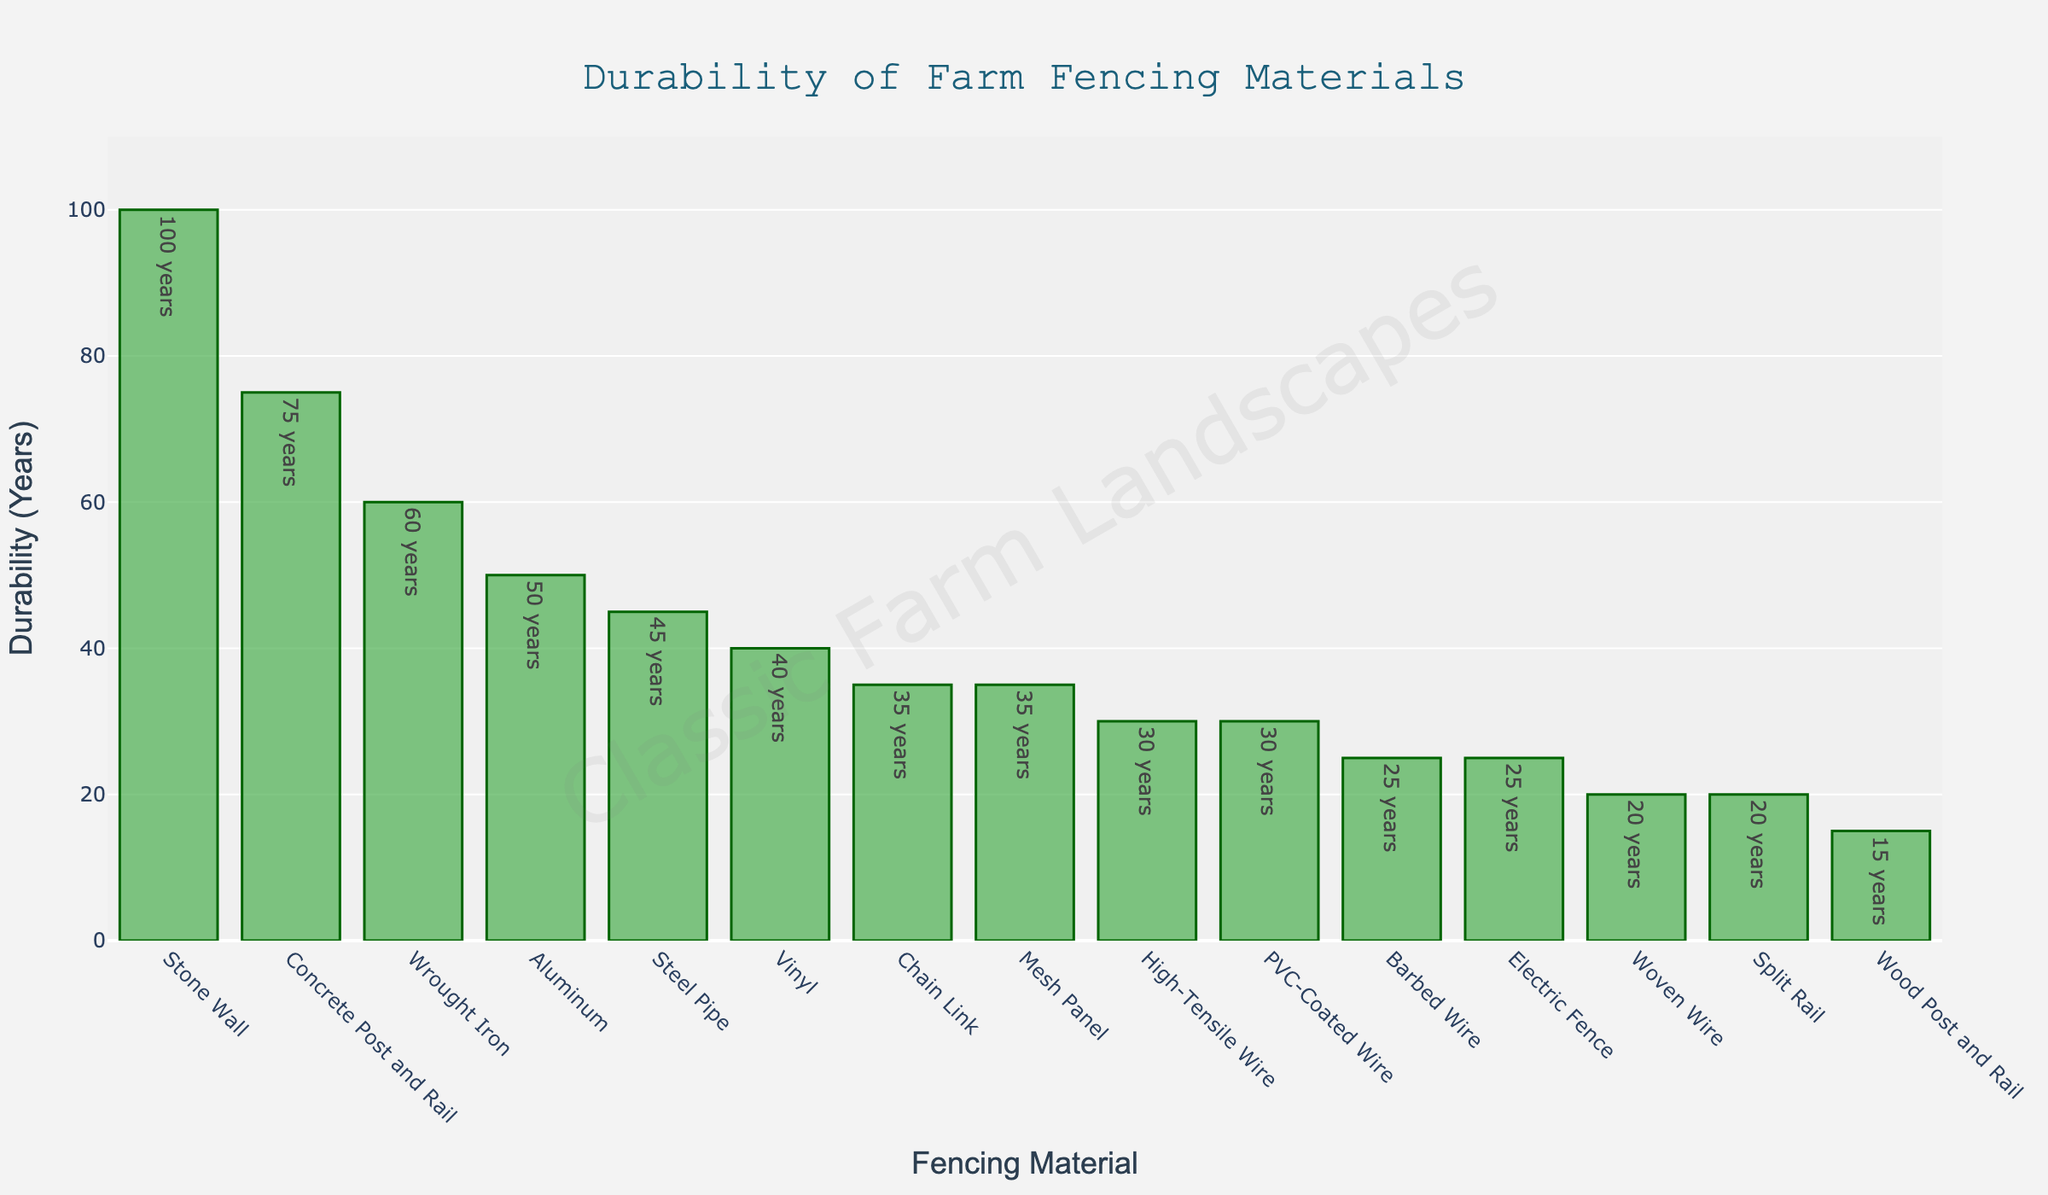What material has the highest durability rating? Identify the highest bar on the chart. The material for the highest bar is Stone Wall with a durability rating of 100 years.
Answer: Stone Wall Which materials have a durability rating of 35 years? Find all bars that are labeled with a durability of 35 years. Chain Link and Mesh Panel both have a 35-year rating.
Answer: Chain Link, Mesh Panel How does the durability of Wrought Iron compare to that of Vinyl? Locate the bars for Wrought Iron and Vinyl. Wrought Iron has a higher durability rating (60 years) compared to Vinyl (40 years).
Answer: Wrought Iron is more durable What is the difference in durability rating between the least durable and most durable materials? Identify the materials with the highest and lowest durability ratings (100 years for Stone Wall and 15 years for Wood Post and Rail respectively). Subtract the lowest from the highest: 100 - 15 = 85.
Answer: 85 years Which material has a durability rating closest to 50 years? Find the bar closest to the 50-year mark. Aluminum has a rating of 50 years, exactly matching the criterion.
Answer: Aluminum What is the total durability rating of Woven Wire, Barbed Wire, and High-Tensile Wire combined? Add the durability ratings of Woven Wire (20), Barbed Wire (25), and High-Tensile Wire (30): 20 + 25 + 30 = 75.
Answer: 75 years Are there more materials with a durability rating below 30 years or above 30 years? Count the number of materials below 30 years and those above 30 years. Below 30: Wood Post and Rail, Woven Wire = 2; Above 30: High-Tensile Wire, Electric Fence, Chain Link, Vinyl, Aluminum, Steel Pipe, Wrought Iron, PVC-Coated Wire, Mesh Panel, Split Rail, Stone Wall, Concrete Post and Rail = 12.
Answer: Above 30 years What is the median durability rating of all the materials? List all durability ratings in ascending order and find the middle value: (15, 20, 20, 25, 25, 30, 30, 35, 35, 40, 45, 50, 60, 75, 100). The median (8th value) is 35.
Answer: 35 years Which material has the same durability rating as Electric Fence? Identify the bar with the same height as Electric Fence (25 years). Barbed Wire also has a 25-year rating.
Answer: Barbed Wire What is the average durability rating of all materials? Sum all the durability ratings and divide by the number of materials: (15 + 20 + 25 + 30 + 25 + 35 + 40 + 50 + 45 + 60 + 30 + 35 + 20 + 100 + 75) / 15. The total sum is 605; therefore, the average is 605 / 15 = 40.33.
Answer: 40.33 years 